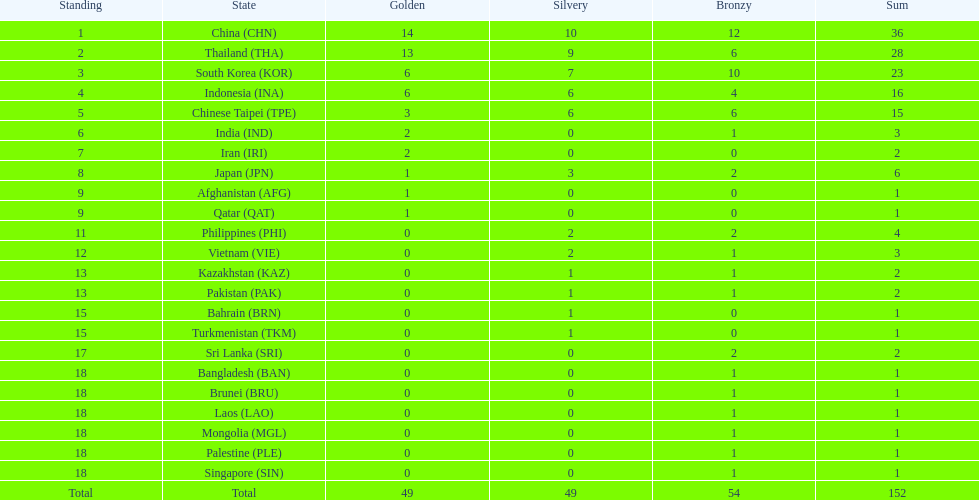Which countries obtained the same amount of gold medals as japan? Afghanistan (AFG), Qatar (QAT). 